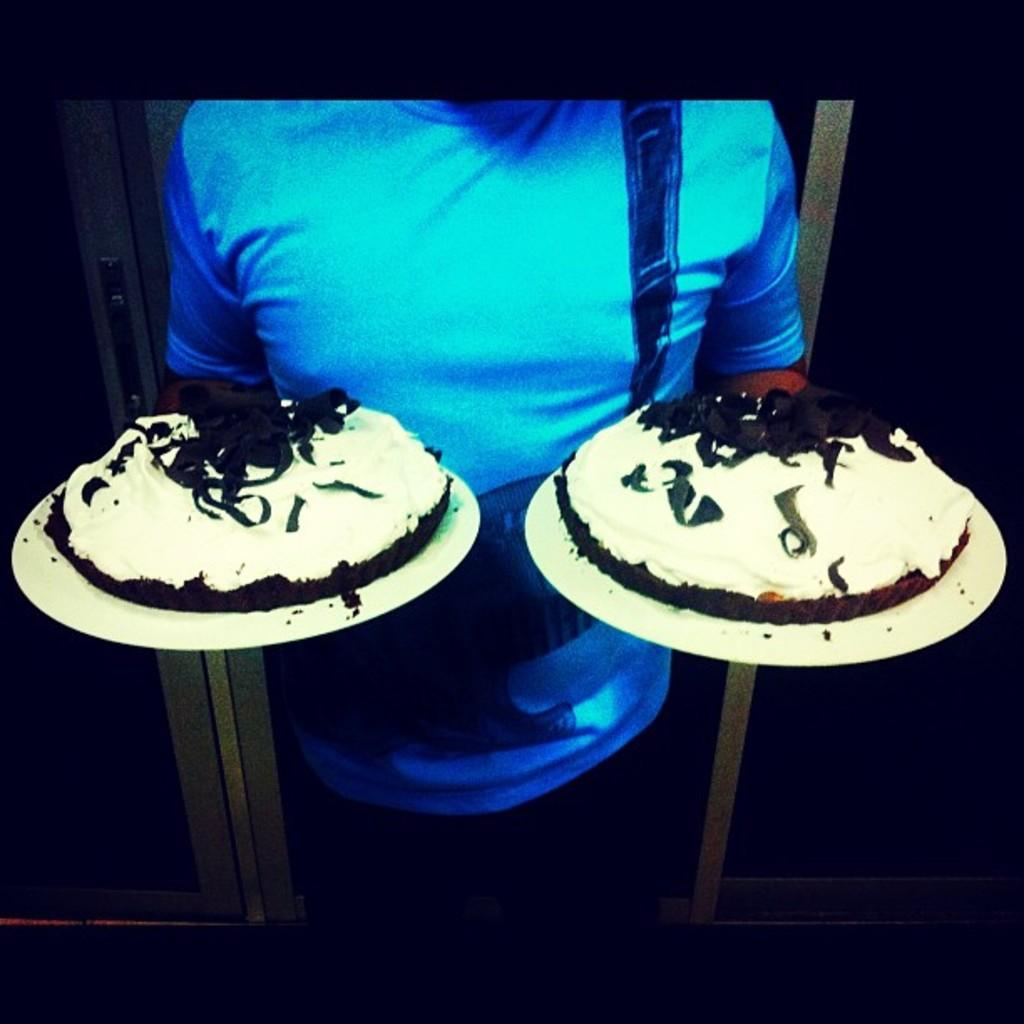What is the person in the image doing? The person is standing and holding two plates. What is on each of the plates? Each plate has a cake on it. Can you describe the background of the image? There is a door visible in the background of the image. What type of engine is powering the cakes in the image? There is no engine present in the image, and the cakes are not powered by any engine. 